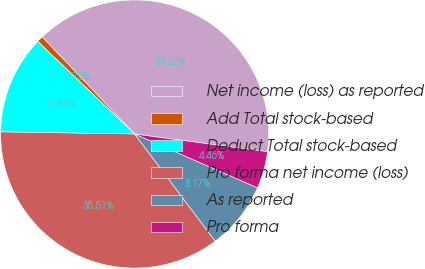<chart> <loc_0><loc_0><loc_500><loc_500><pie_chart><fcel>Net income (loss) as reported<fcel>Add Total stock-based<fcel>Deduct Total stock-based<fcel>Pro forma net income (loss)<fcel>As reported<fcel>Pro forma<nl><fcel>39.22%<fcel>0.75%<fcel>11.88%<fcel>35.51%<fcel>8.17%<fcel>4.46%<nl></chart> 